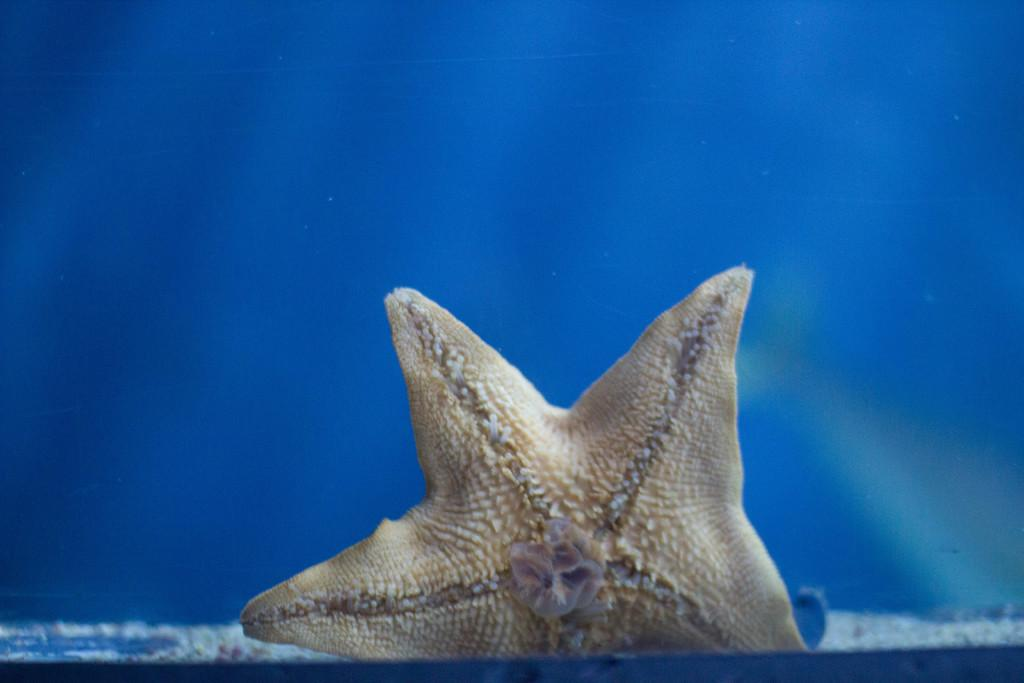What is the main subject of the image? There is a starfish in the image. What color is the starfish? The starfish is cream in color. What can be seen in the background of the image? The background of the image is blue. Can you tell me how many girls are walking with a soda in the image? There are no girls or soda present in the image; it features a starfish on a blue background. 